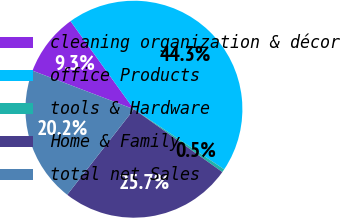Convert chart to OTSL. <chart><loc_0><loc_0><loc_500><loc_500><pie_chart><fcel>cleaning organization & décor<fcel>office Products<fcel>tools & Hardware<fcel>Home & Family<fcel>total net Sales<nl><fcel>9.29%<fcel>44.29%<fcel>0.48%<fcel>25.71%<fcel>20.24%<nl></chart> 